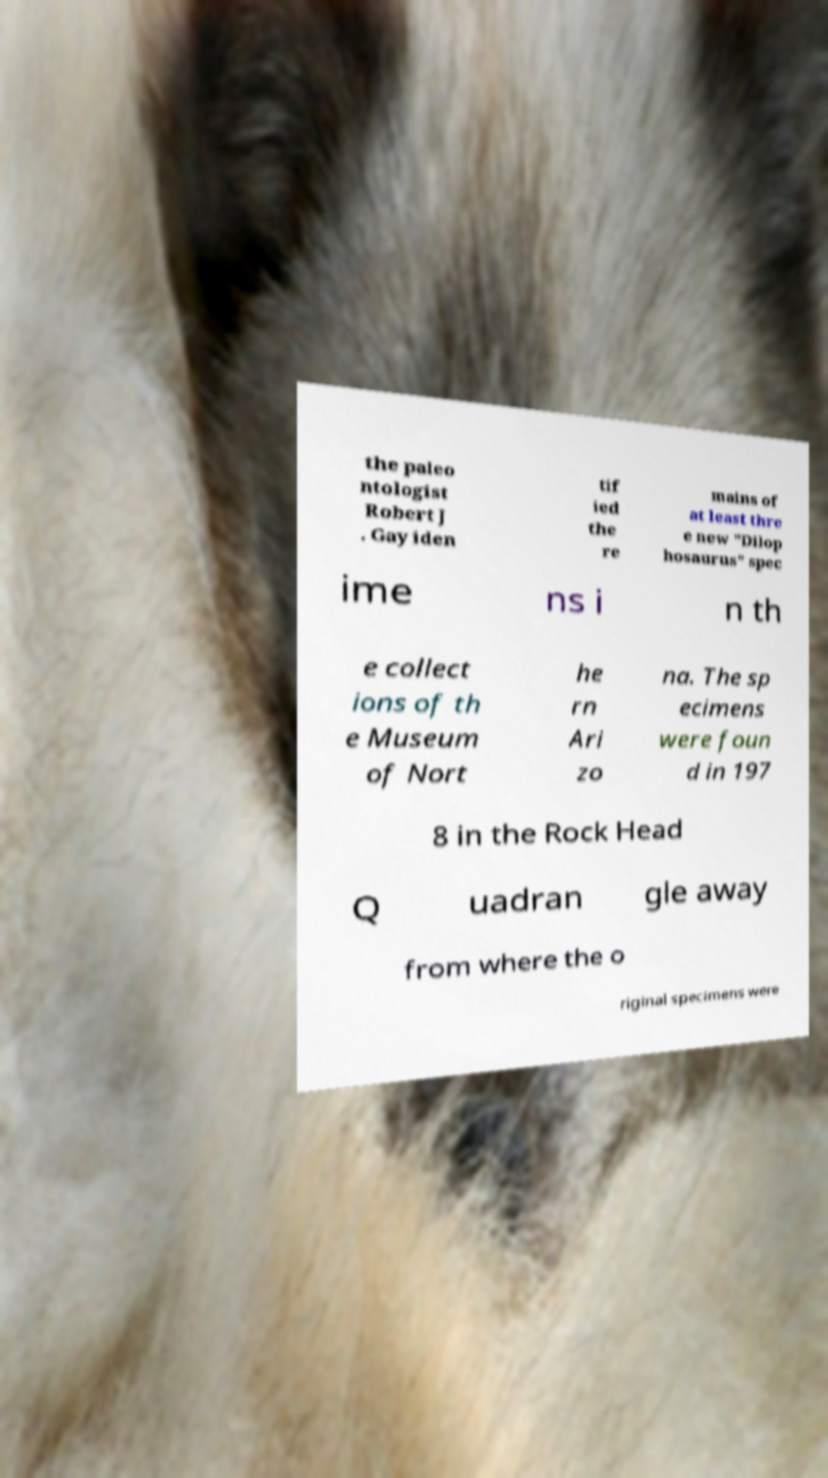Please read and relay the text visible in this image. What does it say? the paleo ntologist Robert J . Gay iden tif ied the re mains of at least thre e new "Dilop hosaurus" spec ime ns i n th e collect ions of th e Museum of Nort he rn Ari zo na. The sp ecimens were foun d in 197 8 in the Rock Head Q uadran gle away from where the o riginal specimens were 